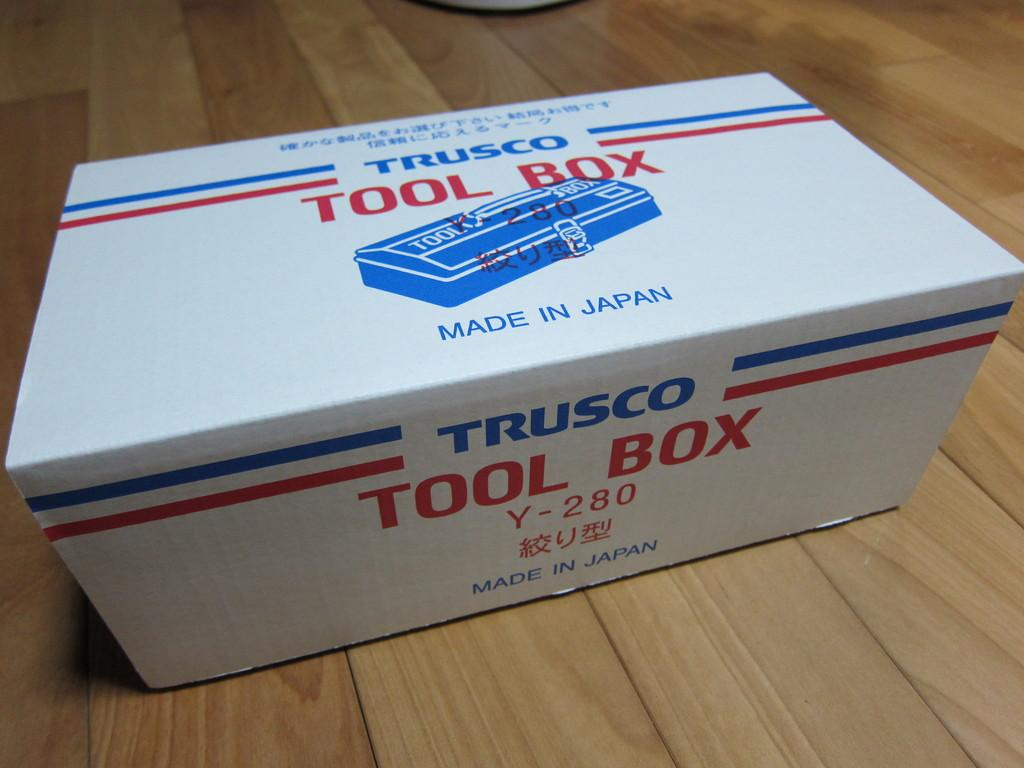<image>
Share a concise interpretation of the image provided. A white box sitting on the floor with the writing Trusco Tool Box. 